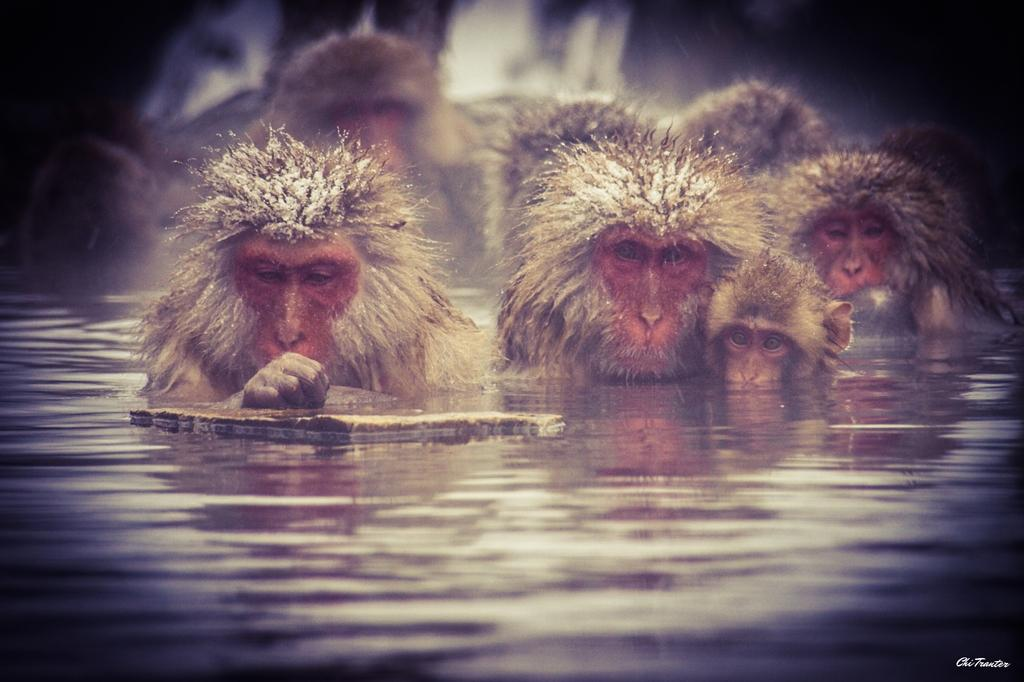What animals are present in the image? There are monkeys in the image. What is the environment in which the monkeys are located? The monkeys are in water. What type of skirt is the monkey wearing in the image? There are no skirts present in the image, as the monkeys are in water and not wearing any clothing. 